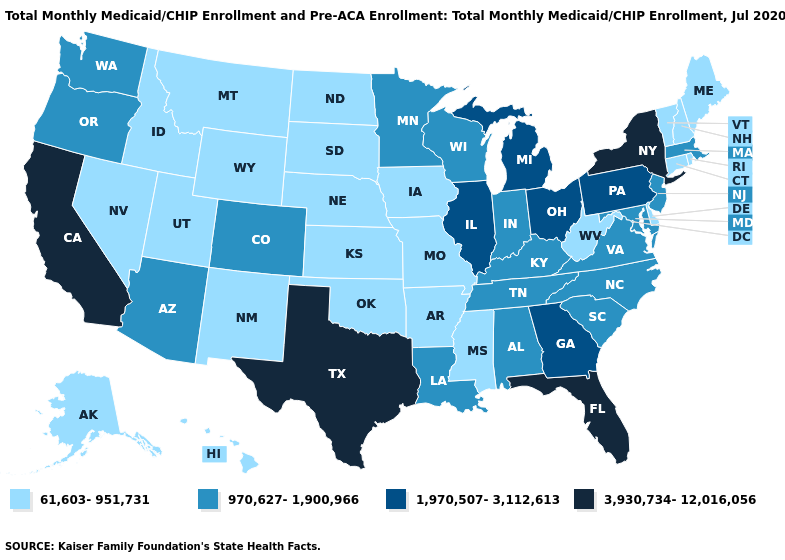What is the value of Rhode Island?
Quick response, please. 61,603-951,731. What is the value of North Dakota?
Answer briefly. 61,603-951,731. What is the lowest value in the USA?
Write a very short answer. 61,603-951,731. Name the states that have a value in the range 61,603-951,731?
Concise answer only. Alaska, Arkansas, Connecticut, Delaware, Hawaii, Idaho, Iowa, Kansas, Maine, Mississippi, Missouri, Montana, Nebraska, Nevada, New Hampshire, New Mexico, North Dakota, Oklahoma, Rhode Island, South Dakota, Utah, Vermont, West Virginia, Wyoming. Name the states that have a value in the range 1,970,507-3,112,613?
Be succinct. Georgia, Illinois, Michigan, Ohio, Pennsylvania. Among the states that border North Carolina , does Georgia have the lowest value?
Keep it brief. No. Does Texas have the highest value in the USA?
Concise answer only. Yes. Name the states that have a value in the range 1,970,507-3,112,613?
Be succinct. Georgia, Illinois, Michigan, Ohio, Pennsylvania. What is the highest value in states that border North Carolina?
Answer briefly. 1,970,507-3,112,613. Name the states that have a value in the range 61,603-951,731?
Keep it brief. Alaska, Arkansas, Connecticut, Delaware, Hawaii, Idaho, Iowa, Kansas, Maine, Mississippi, Missouri, Montana, Nebraska, Nevada, New Hampshire, New Mexico, North Dakota, Oklahoma, Rhode Island, South Dakota, Utah, Vermont, West Virginia, Wyoming. Is the legend a continuous bar?
Answer briefly. No. What is the value of Wyoming?
Give a very brief answer. 61,603-951,731. Name the states that have a value in the range 3,930,734-12,016,056?
Short answer required. California, Florida, New York, Texas. Name the states that have a value in the range 3,930,734-12,016,056?
Be succinct. California, Florida, New York, Texas. Does Connecticut have the highest value in the Northeast?
Answer briefly. No. 